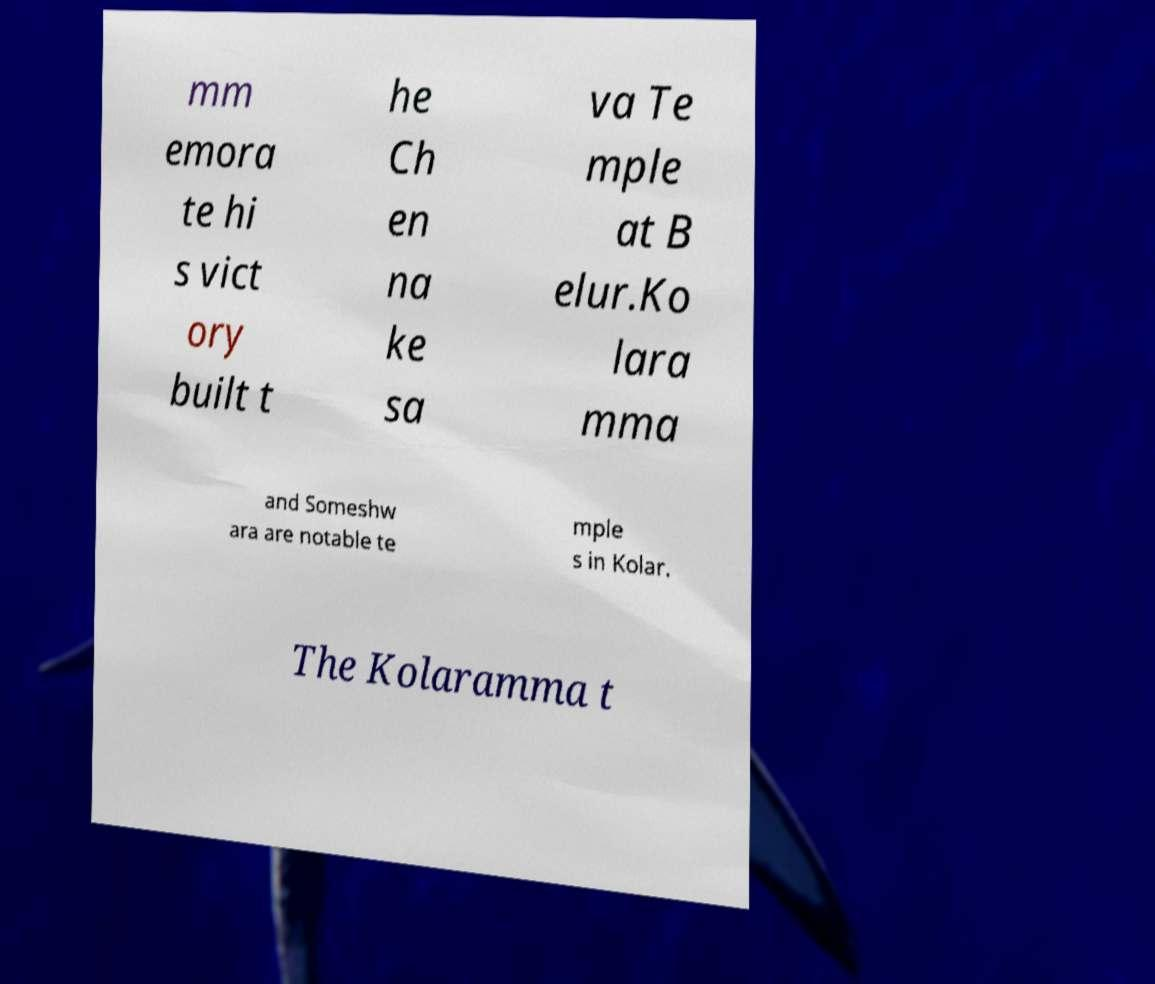Please identify and transcribe the text found in this image. mm emora te hi s vict ory built t he Ch en na ke sa va Te mple at B elur.Ko lara mma and Someshw ara are notable te mple s in Kolar. The Kolaramma t 